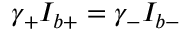Convert formula to latex. <formula><loc_0><loc_0><loc_500><loc_500>\gamma _ { + } I _ { b + } = \gamma _ { - } I _ { b - }</formula> 